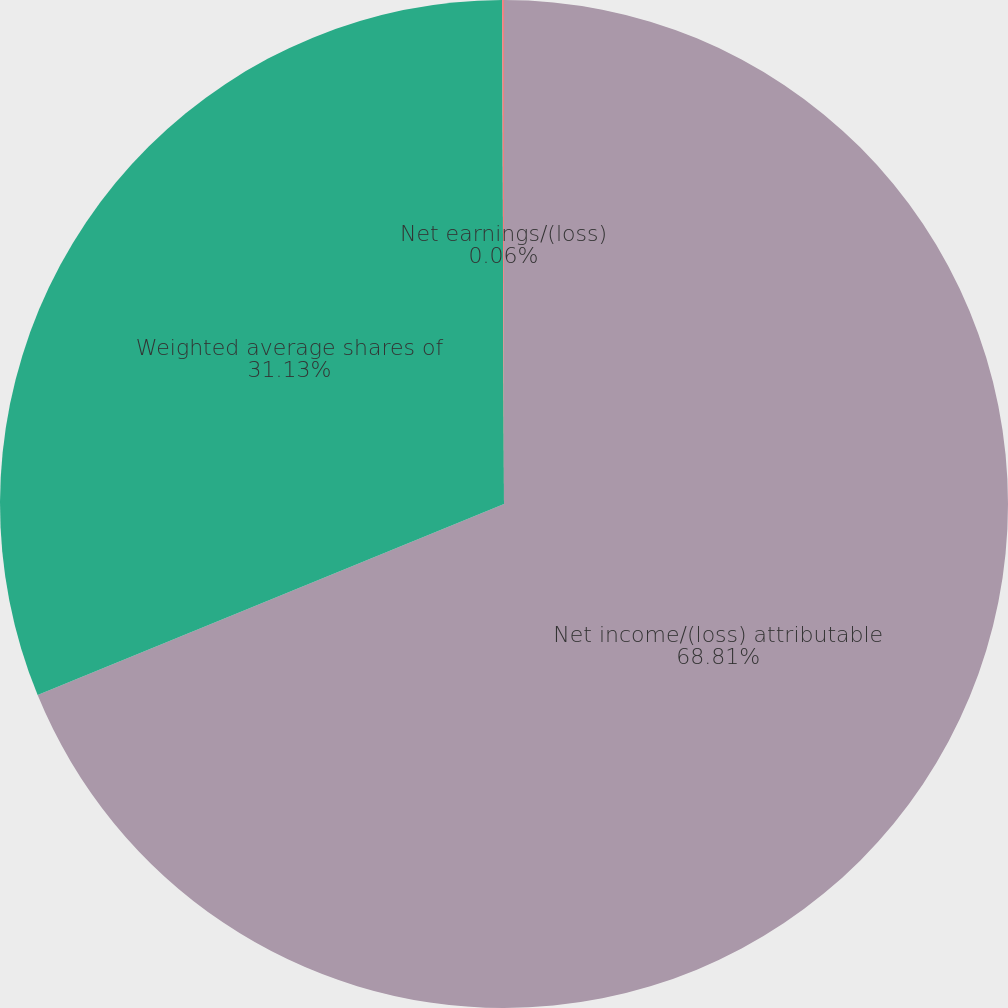<chart> <loc_0><loc_0><loc_500><loc_500><pie_chart><fcel>Net income/(loss) attributable<fcel>Weighted average shares of<fcel>Net earnings/(loss)<nl><fcel>68.81%<fcel>31.13%<fcel>0.06%<nl></chart> 